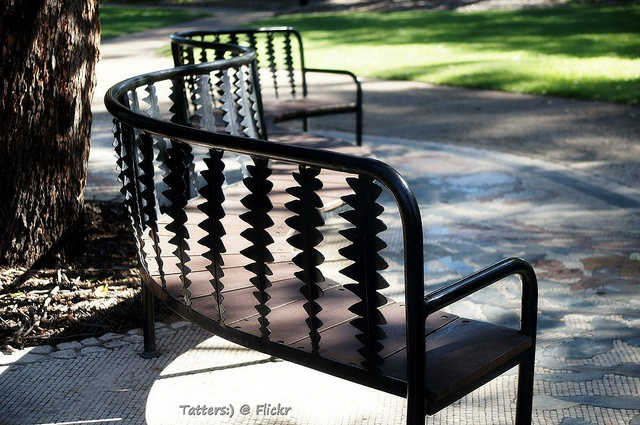Describe the objects in this image and their specific colors. I can see a bench in black, lightgray, gray, and darkgray tones in this image. 